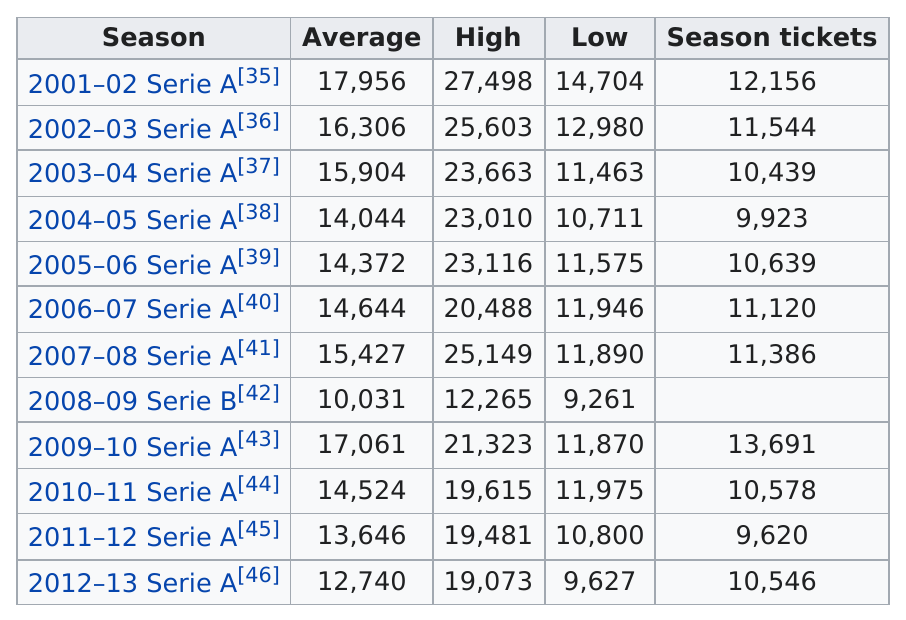Mention a couple of crucial points in this snapshot. In 2007, there were 11,386 season tickets. In 2008, the average attendance was 10,031. The highest attendance recorded during the 2008-09 season at Stadio Ennio Tardini was 3004, while the lowest attendance during the same season was 3004. In 2001, the average score was 17,956. The Stadio Ennio Tardini had an average attendance of at least 15,000 for five seasons. 